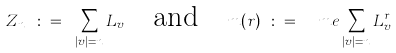<formula> <loc_0><loc_0><loc_500><loc_500>Z _ { n } \ \colon = \ \sum _ { | v | = n } L _ { v } \quad \text {and} \quad m ( r ) \ \colon = \ \ m e \sum _ { | v | = n } L ^ { r } _ { v }</formula> 